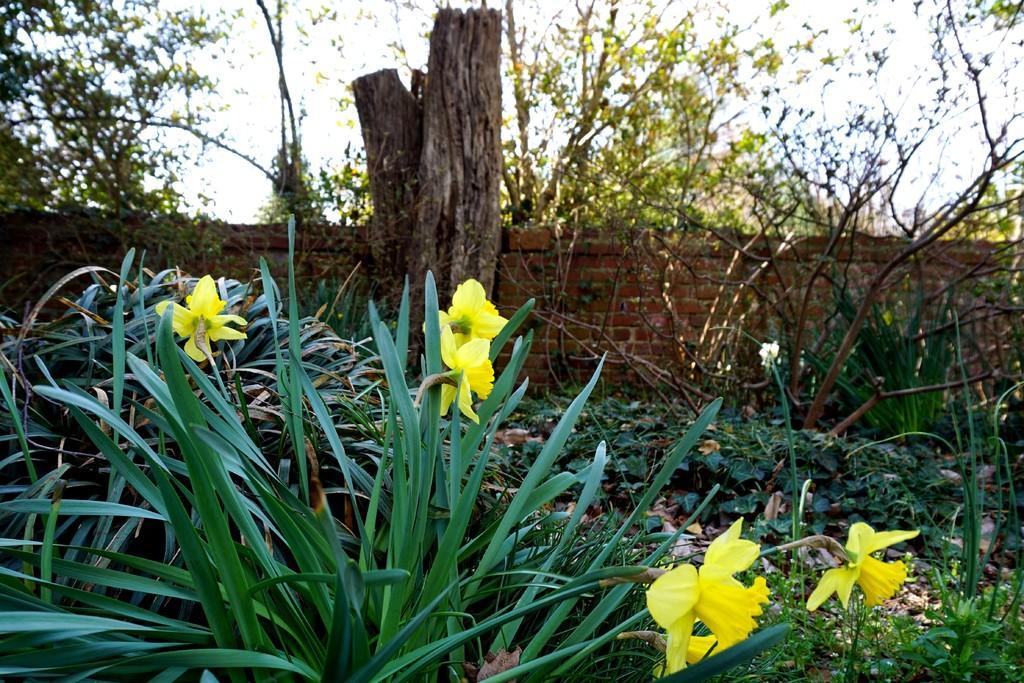Could you give a brief overview of what you see in this image? In this image, we can see some plants and trees. There are stems in front of the wall. 